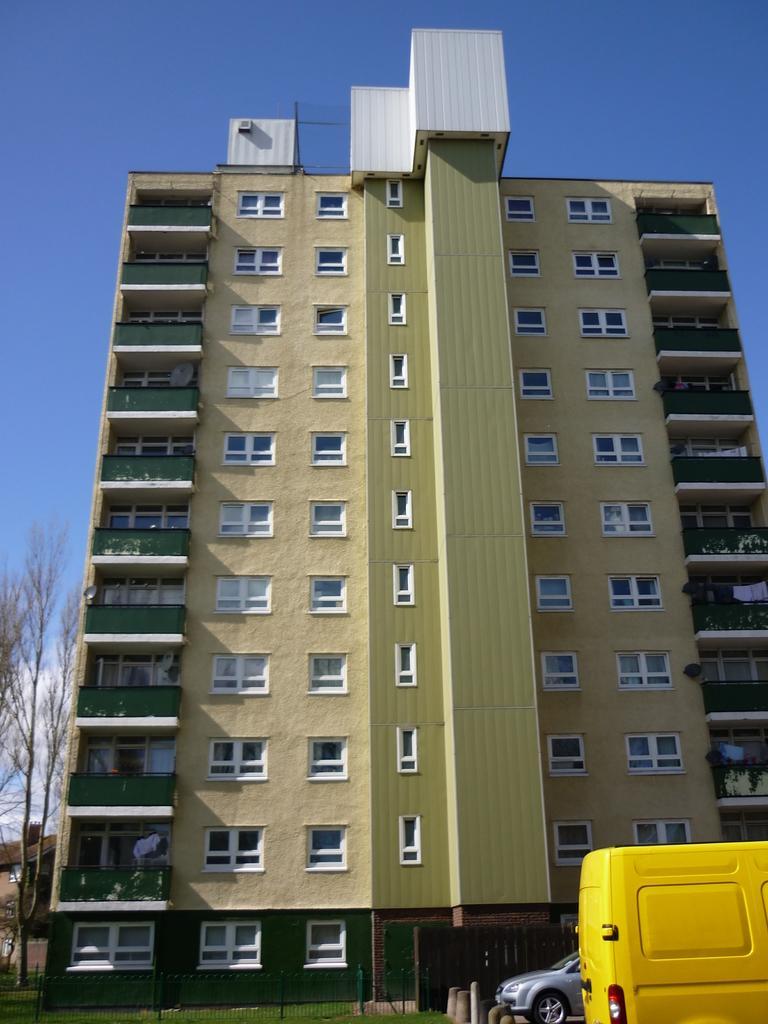In one or two sentences, can you explain what this image depicts? Here we can see a building. There are vehicles, fence, grass, and trees. In the background there is sky. 